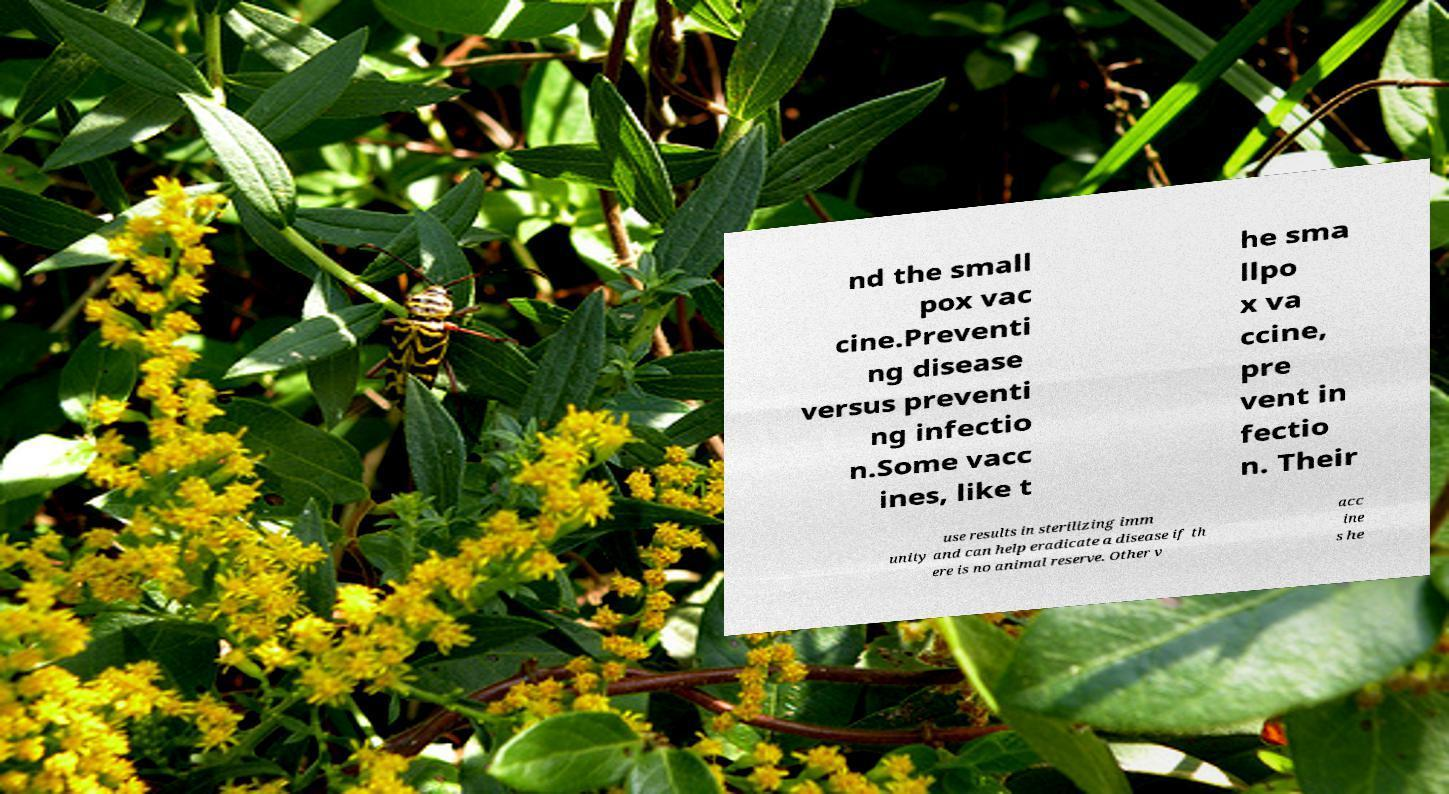Could you assist in decoding the text presented in this image and type it out clearly? nd the small pox vac cine.Preventi ng disease versus preventi ng infectio n.Some vacc ines, like t he sma llpo x va ccine, pre vent in fectio n. Their use results in sterilizing imm unity and can help eradicate a disease if th ere is no animal reserve. Other v acc ine s he 